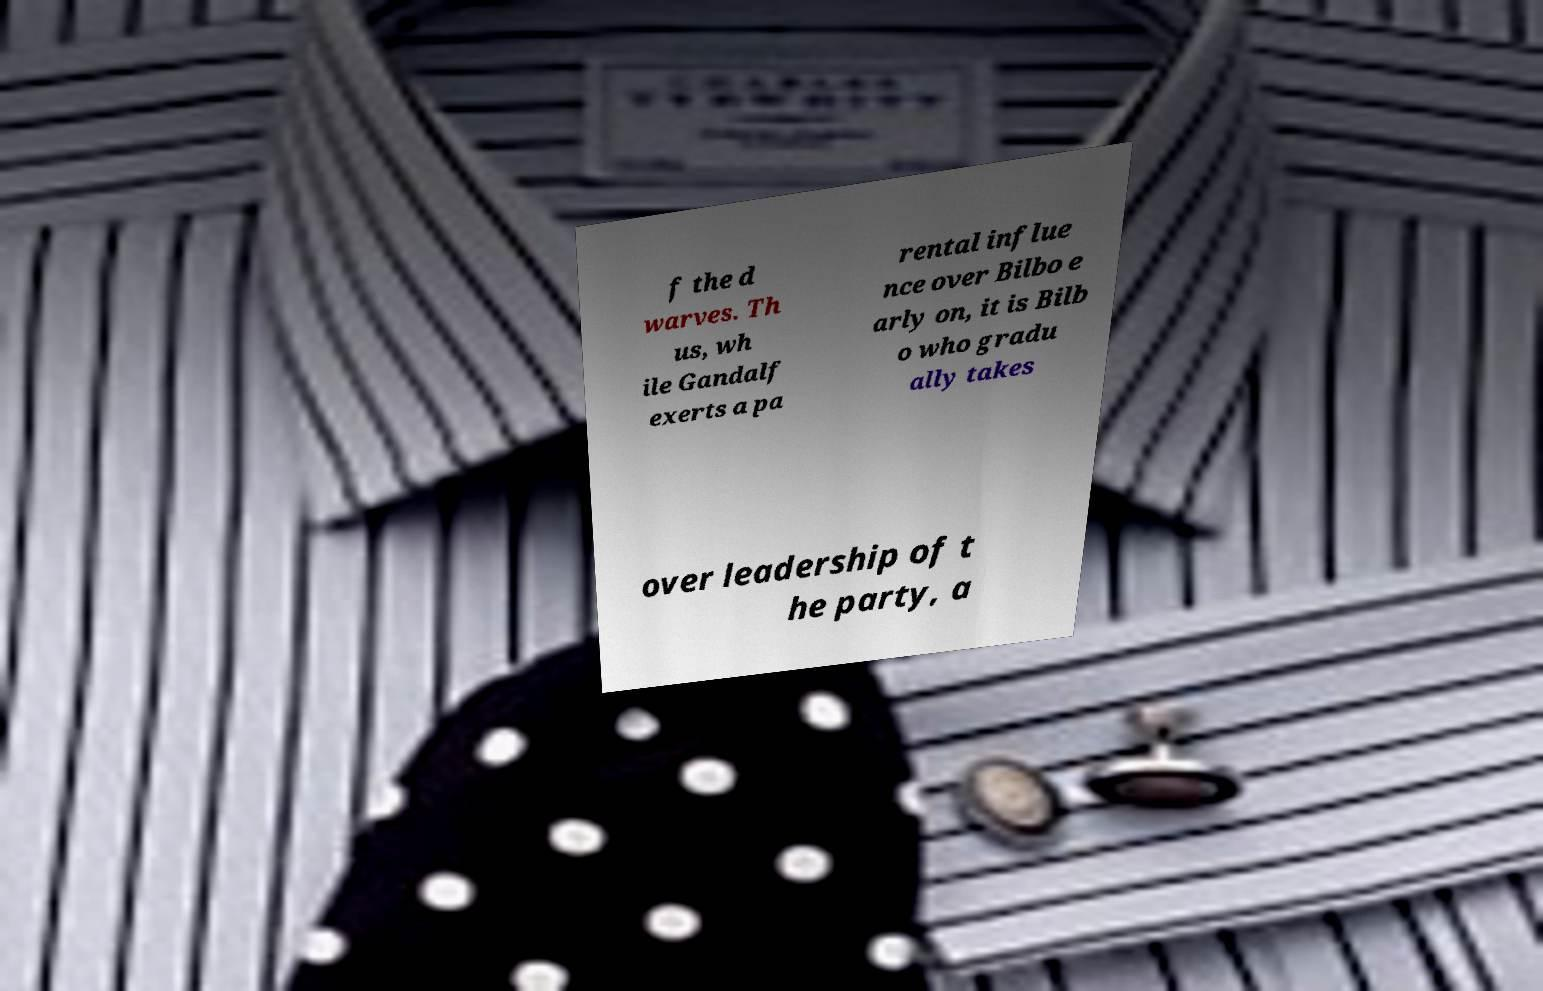Please identify and transcribe the text found in this image. f the d warves. Th us, wh ile Gandalf exerts a pa rental influe nce over Bilbo e arly on, it is Bilb o who gradu ally takes over leadership of t he party, a 